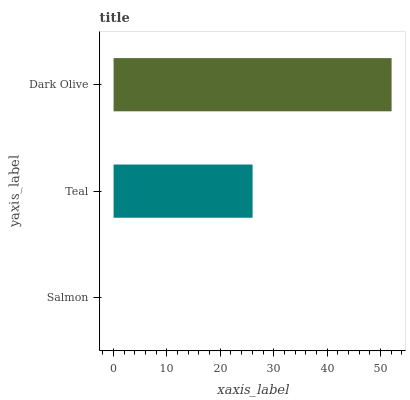Is Salmon the minimum?
Answer yes or no. Yes. Is Dark Olive the maximum?
Answer yes or no. Yes. Is Teal the minimum?
Answer yes or no. No. Is Teal the maximum?
Answer yes or no. No. Is Teal greater than Salmon?
Answer yes or no. Yes. Is Salmon less than Teal?
Answer yes or no. Yes. Is Salmon greater than Teal?
Answer yes or no. No. Is Teal less than Salmon?
Answer yes or no. No. Is Teal the high median?
Answer yes or no. Yes. Is Teal the low median?
Answer yes or no. Yes. Is Dark Olive the high median?
Answer yes or no. No. Is Salmon the low median?
Answer yes or no. No. 